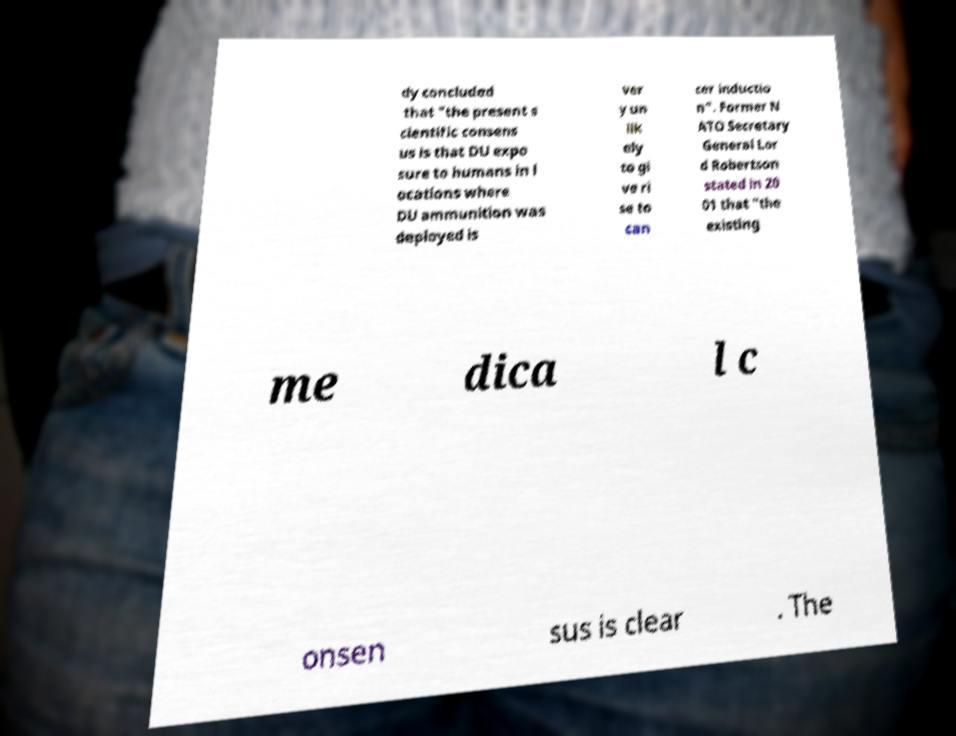Please identify and transcribe the text found in this image. dy concluded that "the present s cientific consens us is that DU expo sure to humans in l ocations where DU ammunition was deployed is ver y un lik ely to gi ve ri se to can cer inductio n". Former N ATO Secretary General Lor d Robertson stated in 20 01 that "the existing me dica l c onsen sus is clear . The 